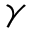<formula> <loc_0><loc_0><loc_500><loc_500>\gamma</formula> 